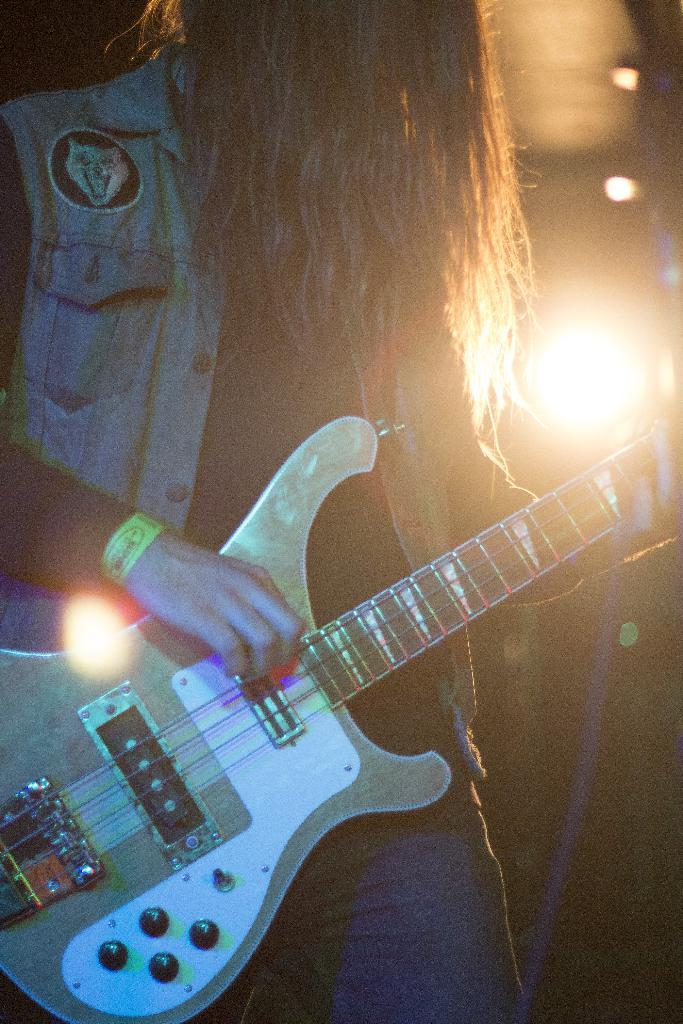What is the main subject of the image? There is a person in the image. What is the person doing in the image? The person is standing and playing the guitar. What object is the person holding in the image? The person is holding a guitar. How many coils can be seen in the image? There are no coils present in the image. What type of chairs are visible in the image? There are no chairs present in the image. 